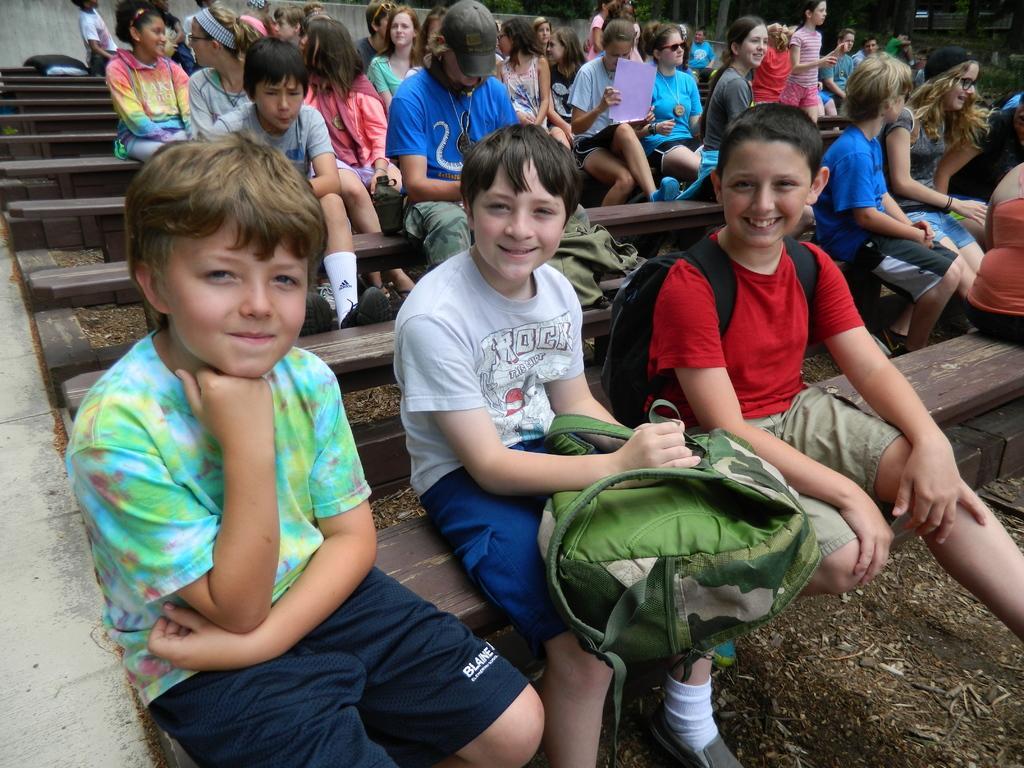Describe this image in one or two sentences. The picture consists of benches, of the benches there are boys, girls sitting and there are backpacks. In the background there are trees and wall. 